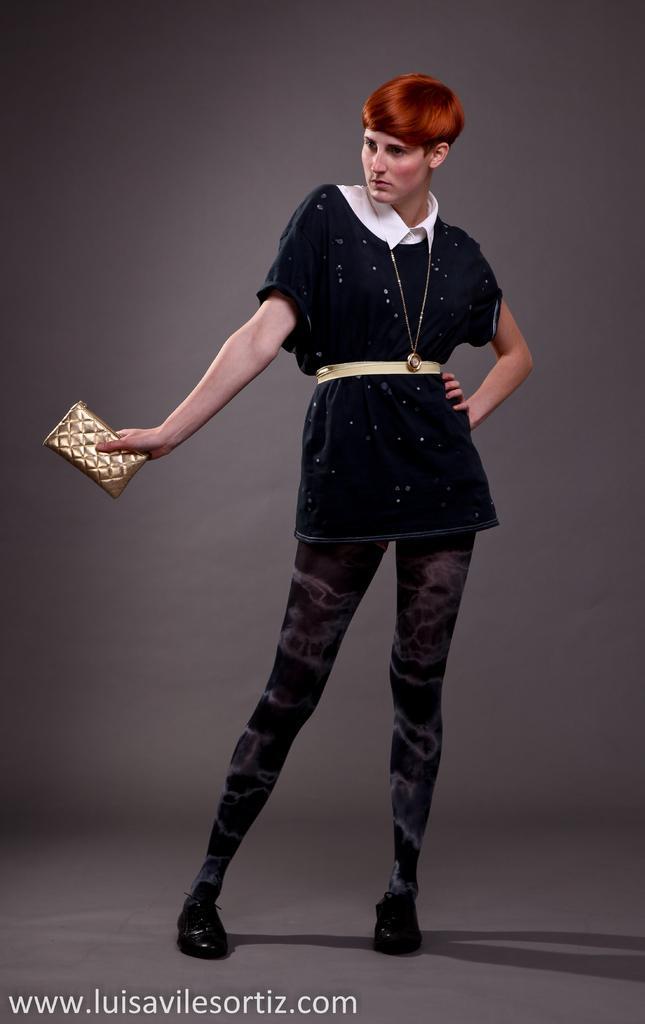Describe this image in one or two sentences. This image consists of a woman wearing a black dress and holding a purse. At the bottom, there is a floor. In the background, there is a wall. 